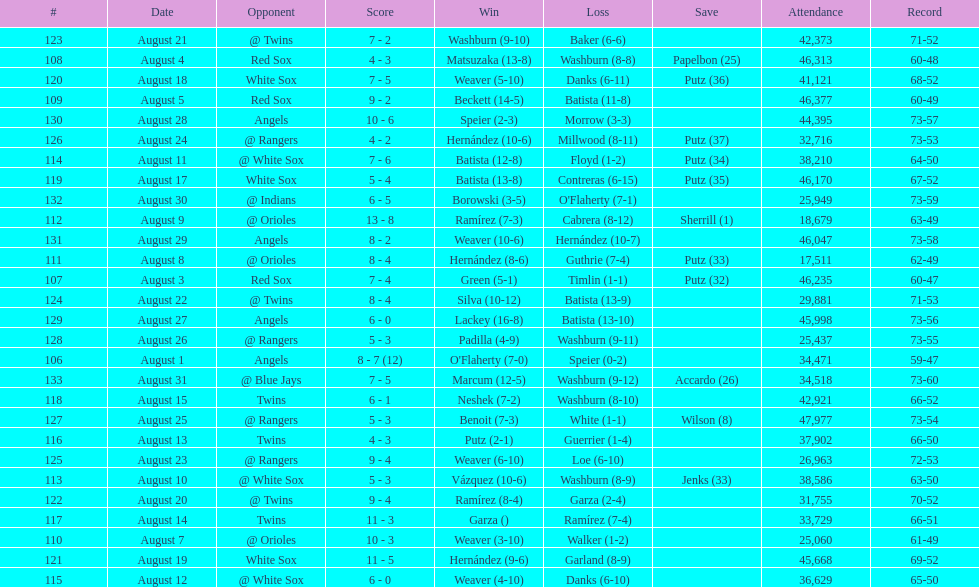How many losses during stretch? 7. 